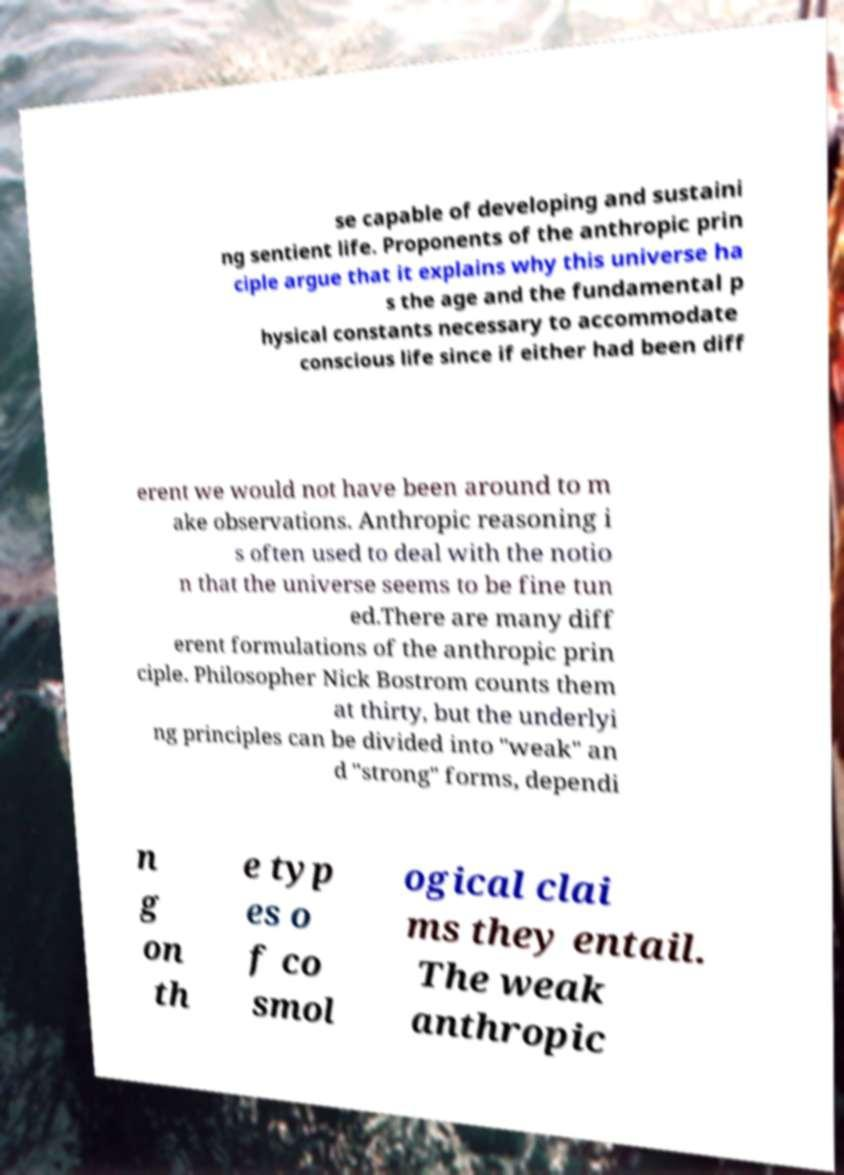What messages or text are displayed in this image? I need them in a readable, typed format. se capable of developing and sustaini ng sentient life. Proponents of the anthropic prin ciple argue that it explains why this universe ha s the age and the fundamental p hysical constants necessary to accommodate conscious life since if either had been diff erent we would not have been around to m ake observations. Anthropic reasoning i s often used to deal with the notio n that the universe seems to be fine tun ed.There are many diff erent formulations of the anthropic prin ciple. Philosopher Nick Bostrom counts them at thirty, but the underlyi ng principles can be divided into "weak" an d "strong" forms, dependi n g on th e typ es o f co smol ogical clai ms they entail. The weak anthropic 